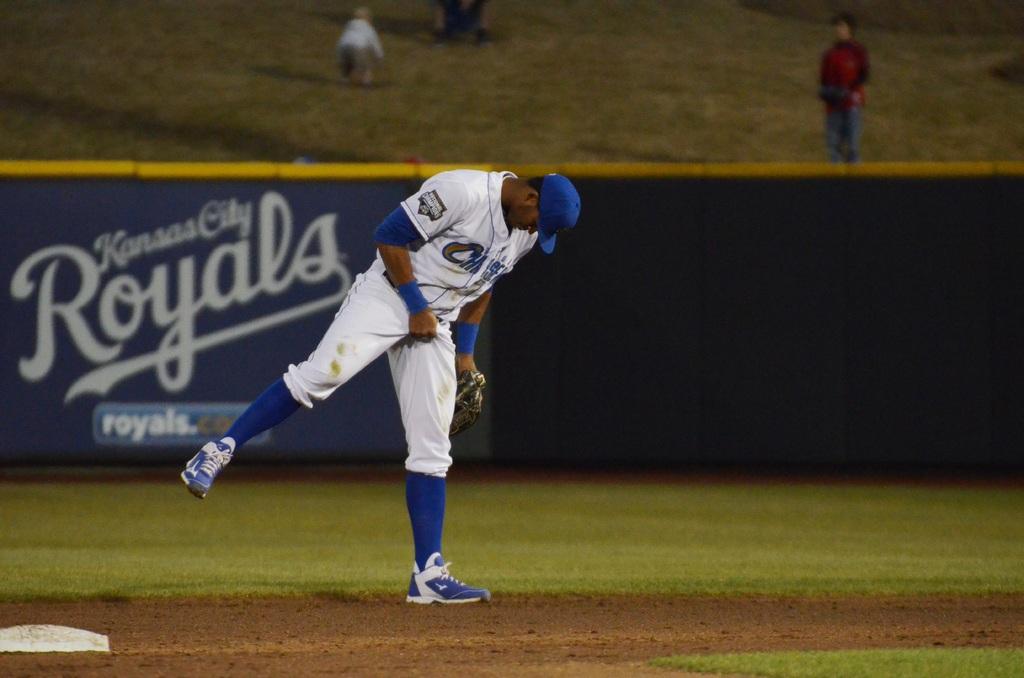What team is playing?
Keep it short and to the point. Kansas city royals. What team plays for kansas city?
Keep it short and to the point. Royals. 